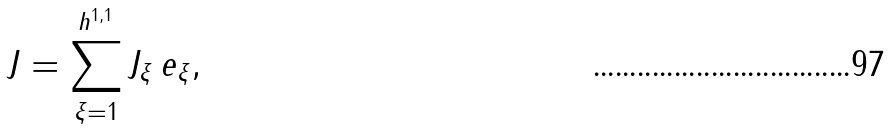<formula> <loc_0><loc_0><loc_500><loc_500>J = \sum _ { \xi = 1 } ^ { h ^ { 1 , 1 } } J _ { \xi } \, e _ { \xi } ,</formula> 